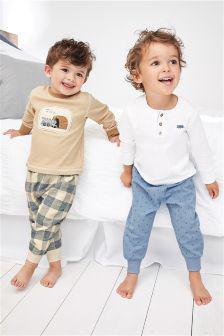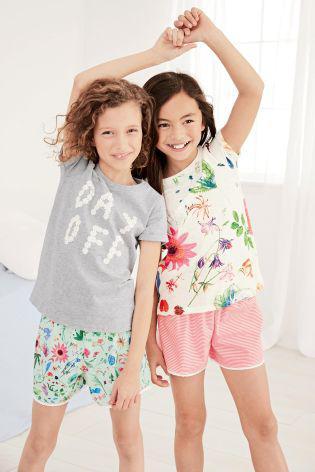The first image is the image on the left, the second image is the image on the right. Given the left and right images, does the statement "In the left image, the kids are holding each other's hands." hold true? Answer yes or no. No. 